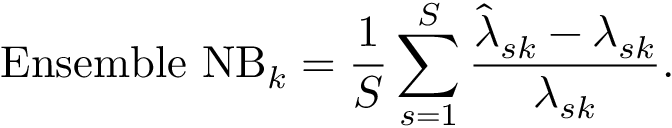<formula> <loc_0><loc_0><loc_500><loc_500>E n s e m b l e N B _ { k } = \frac { 1 } { S } \sum _ { s = 1 } ^ { S } \frac { \hat { \lambda } _ { s k } - { { \lambda } _ { s k } } } { { { \lambda } _ { s k } } } .</formula> 